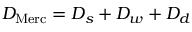<formula> <loc_0><loc_0><loc_500><loc_500>D _ { M e r c } = D _ { s } + D _ { w } + D _ { d }</formula> 